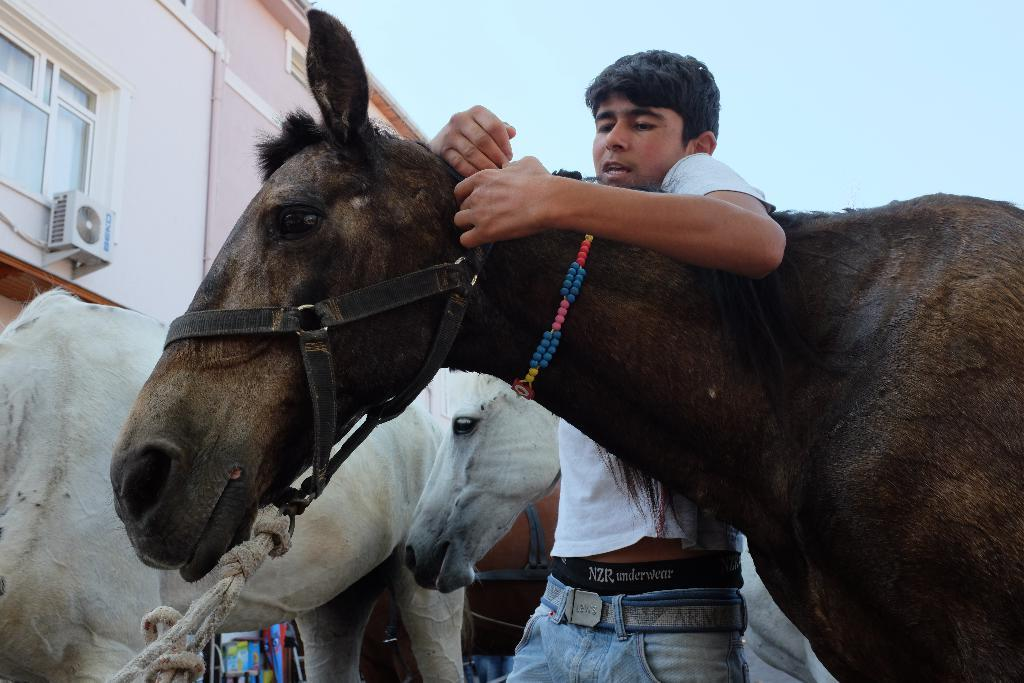What can be seen at the top of the image? The sky is visible at the top of the image. What type of structure is present in the image? There is a building in the image. What feature of the building is mentioned in the facts? The building has windows. What animals are in the image? There are horses in the image. What is the color scheme of the horses? The horses are in black and white color. Who else is present in the image? There is a man in the image. What is the man doing with the horse? The man has his hands laid over a horse. Where is the lunchroom located in the image? There is no mention of a lunchroom in the image. --- Facts: 1. There is a car in the image. 12. The car is red. 123. The car has four wheels. 123. The car is parked on the street. 123. There are people walking on the sidewalk. 123. The weather appears to be sunny. Absurd Topics: unicorn, rainbow, umbrella Conversation: What is the main subject in the image? There is a car in the image. What color is the car? The car is red. How many wheels does the car have? The car has four wheels. Where is the car located in the image? The car is parked on the street. What can be seen on the sidewalk? There are people walking on the sidewalk. How is the weather in the image? The weather appears to be sunny. Reasoning: Let's think step by step in order to produce the conversation. We start by identifying the main subject of the image, which is the car. Next, we describe specific features of the car, such as its color and the number of wheels it has. Then, we observe the location of the car in the image, noting that it is parked on the street. After that, we describe the actions of the people walking on the sidewalk. Finally, we describe the weather in the image, which is sunny. Absurd Question/Answer: How many unicorns can be seen playing with a rainbow umbrella in the image? There are no unicorns, rainbows, or umbrellas present in the image. 